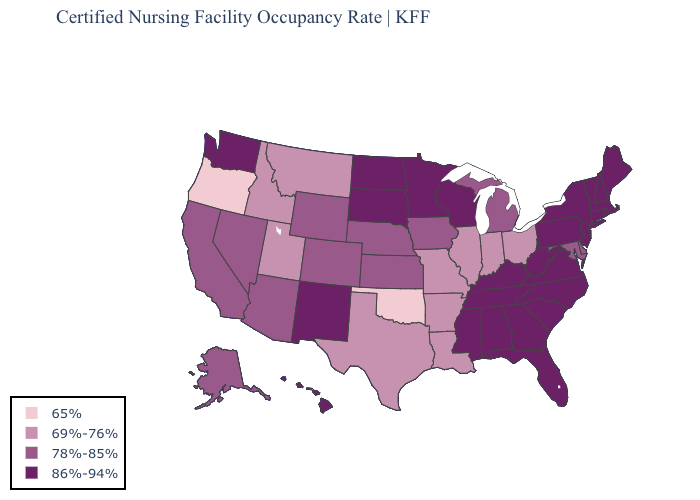Among the states that border Montana , which have the highest value?
Short answer required. North Dakota, South Dakota. Among the states that border Indiana , does Kentucky have the highest value?
Give a very brief answer. Yes. What is the highest value in states that border Oregon?
Be succinct. 86%-94%. Name the states that have a value in the range 65%?
Keep it brief. Oklahoma, Oregon. What is the value of Oklahoma?
Quick response, please. 65%. What is the value of Illinois?
Keep it brief. 69%-76%. Which states hav the highest value in the West?
Quick response, please. Hawaii, New Mexico, Washington. Name the states that have a value in the range 78%-85%?
Keep it brief. Alaska, Arizona, California, Colorado, Delaware, Iowa, Kansas, Maryland, Michigan, Nebraska, Nevada, Wyoming. Which states have the highest value in the USA?
Write a very short answer. Alabama, Connecticut, Florida, Georgia, Hawaii, Kentucky, Maine, Massachusetts, Minnesota, Mississippi, New Hampshire, New Jersey, New Mexico, New York, North Carolina, North Dakota, Pennsylvania, Rhode Island, South Carolina, South Dakota, Tennessee, Vermont, Virginia, Washington, West Virginia, Wisconsin. What is the value of Florida?
Keep it brief. 86%-94%. Name the states that have a value in the range 78%-85%?
Short answer required. Alaska, Arizona, California, Colorado, Delaware, Iowa, Kansas, Maryland, Michigan, Nebraska, Nevada, Wyoming. Name the states that have a value in the range 65%?
Write a very short answer. Oklahoma, Oregon. Does the first symbol in the legend represent the smallest category?
Write a very short answer. Yes. Name the states that have a value in the range 69%-76%?
Be succinct. Arkansas, Idaho, Illinois, Indiana, Louisiana, Missouri, Montana, Ohio, Texas, Utah. 